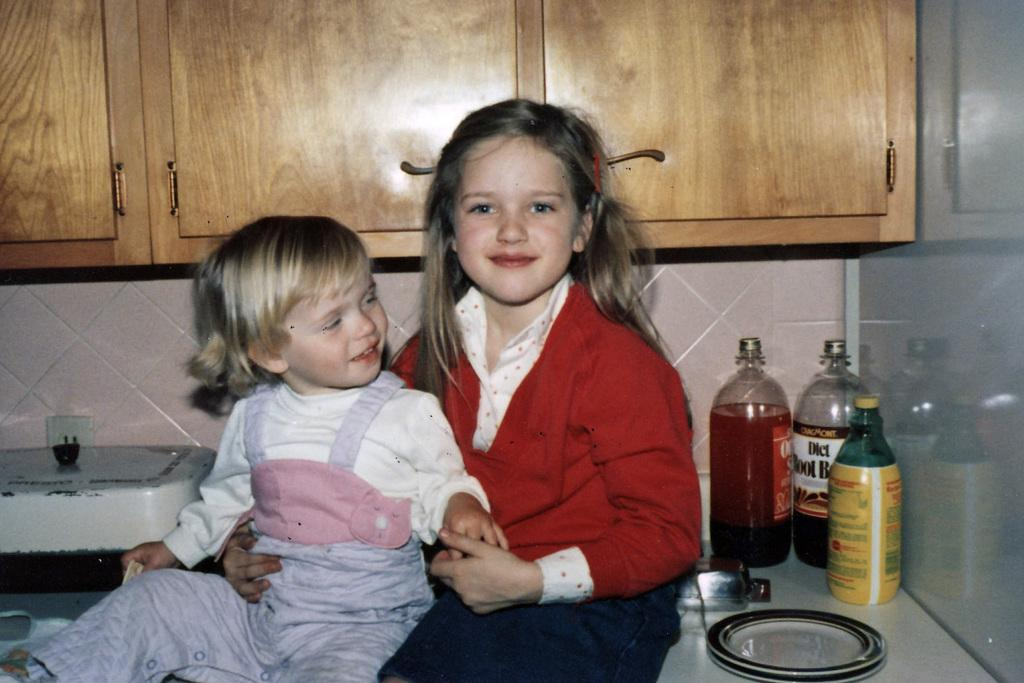<image>
Offer a succinct explanation of the picture presented. A bottle of diet root beer is on the counter behind two kids. 